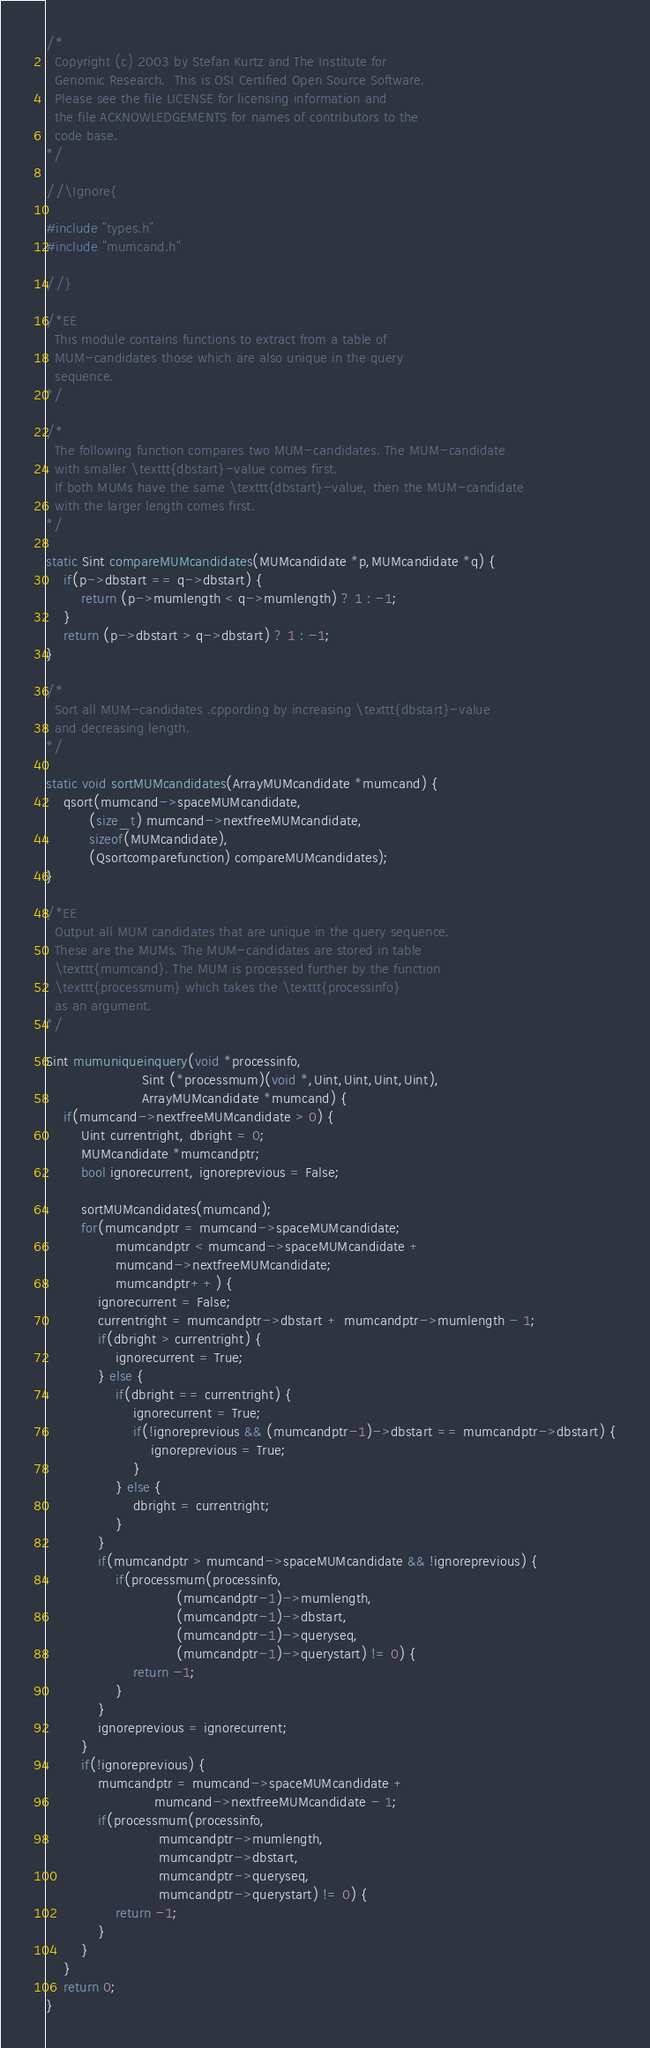Convert code to text. <code><loc_0><loc_0><loc_500><loc_500><_C++_>/*
  Copyright (c) 2003 by Stefan Kurtz and The Institute for
  Genomic Research.  This is OSI Certified Open Source Software.
  Please see the file LICENSE for licensing information and
  the file ACKNOWLEDGEMENTS for names of contributors to the
  code base.
*/

//\Ignore{

#include "types.h"
#include "mumcand.h"

//}

/*EE
  This module contains functions to extract from a table of
  MUM-candidates those which are also unique in the query
  sequence.
*/

/*
  The following function compares two MUM-candidates. The MUM-candidate
  with smaller \texttt{dbstart}-value comes first.
  If both MUMs have the same \texttt{dbstart}-value, then the MUM-candidate
  with the larger length comes first.
*/

static Sint compareMUMcandidates(MUMcandidate *p,MUMcandidate *q) {
    if(p->dbstart == q->dbstart) {
        return (p->mumlength < q->mumlength) ? 1 : -1;
    }
    return (p->dbstart > q->dbstart) ? 1 : -1;
}

/*
  Sort all MUM-candidates .cppording by increasing \texttt{dbstart}-value
  and decreasing length.
*/

static void sortMUMcandidates(ArrayMUMcandidate *mumcand) {
    qsort(mumcand->spaceMUMcandidate,
          (size_t) mumcand->nextfreeMUMcandidate,
          sizeof(MUMcandidate),
          (Qsortcomparefunction) compareMUMcandidates);
}

/*EE
  Output all MUM candidates that are unique in the query sequence.
  These are the MUMs. The MUM-candidates are stored in table
  \texttt{mumcand}. The MUM is processed further by the function
  \texttt{processmum} which takes the \texttt{processinfo}
  as an argument.
*/

Sint mumuniqueinquery(void *processinfo,
                      Sint (*processmum)(void *,Uint,Uint,Uint,Uint),
                      ArrayMUMcandidate *mumcand) {
    if(mumcand->nextfreeMUMcandidate > 0) {
        Uint currentright, dbright = 0;
        MUMcandidate *mumcandptr;
        bool ignorecurrent, ignoreprevious = False;

        sortMUMcandidates(mumcand);
        for(mumcandptr = mumcand->spaceMUMcandidate;
                mumcandptr < mumcand->spaceMUMcandidate +
                mumcand->nextfreeMUMcandidate;
                mumcandptr++) {
            ignorecurrent = False;
            currentright = mumcandptr->dbstart + mumcandptr->mumlength - 1;
            if(dbright > currentright) {
                ignorecurrent = True;
            } else {
                if(dbright == currentright) {
                    ignorecurrent = True;
                    if(!ignoreprevious && (mumcandptr-1)->dbstart == mumcandptr->dbstart) {
                        ignoreprevious = True;
                    }
                } else {
                    dbright = currentright;
                }
            }
            if(mumcandptr > mumcand->spaceMUMcandidate && !ignoreprevious) {
                if(processmum(processinfo,
                              (mumcandptr-1)->mumlength,
                              (mumcandptr-1)->dbstart,
                              (mumcandptr-1)->queryseq,
                              (mumcandptr-1)->querystart) != 0) {
                    return -1;
                }
            }
            ignoreprevious = ignorecurrent;
        }
        if(!ignoreprevious) {
            mumcandptr = mumcand->spaceMUMcandidate +
                         mumcand->nextfreeMUMcandidate - 1;
            if(processmum(processinfo,
                          mumcandptr->mumlength,
                          mumcandptr->dbstart,
                          mumcandptr->queryseq,
                          mumcandptr->querystart) != 0) {
                return -1;
            }
        }
    }
    return 0;
}
</code> 